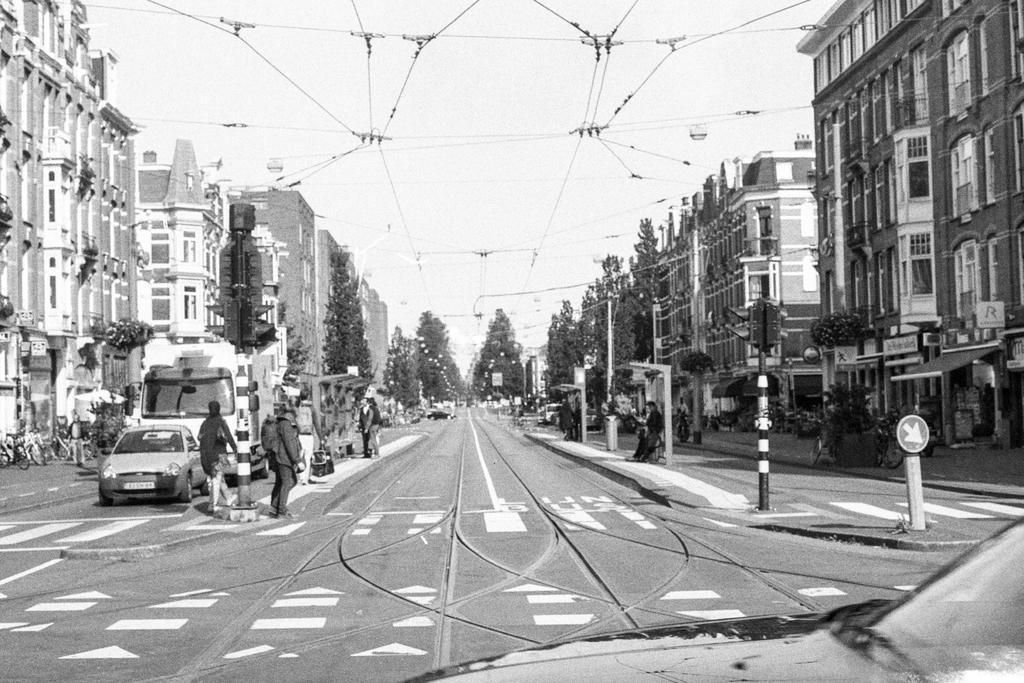Please provide a concise description of this image. It is the black and white image in which we can see that there is a road in the middle. There are buildings on either side of the road. There are few people walking on the footpath. On the left side there are vehicles on the road. At the bottom there is a car. At the top there are wires. There are trees in front of the buildings. There are boards and poles on the footpath. 